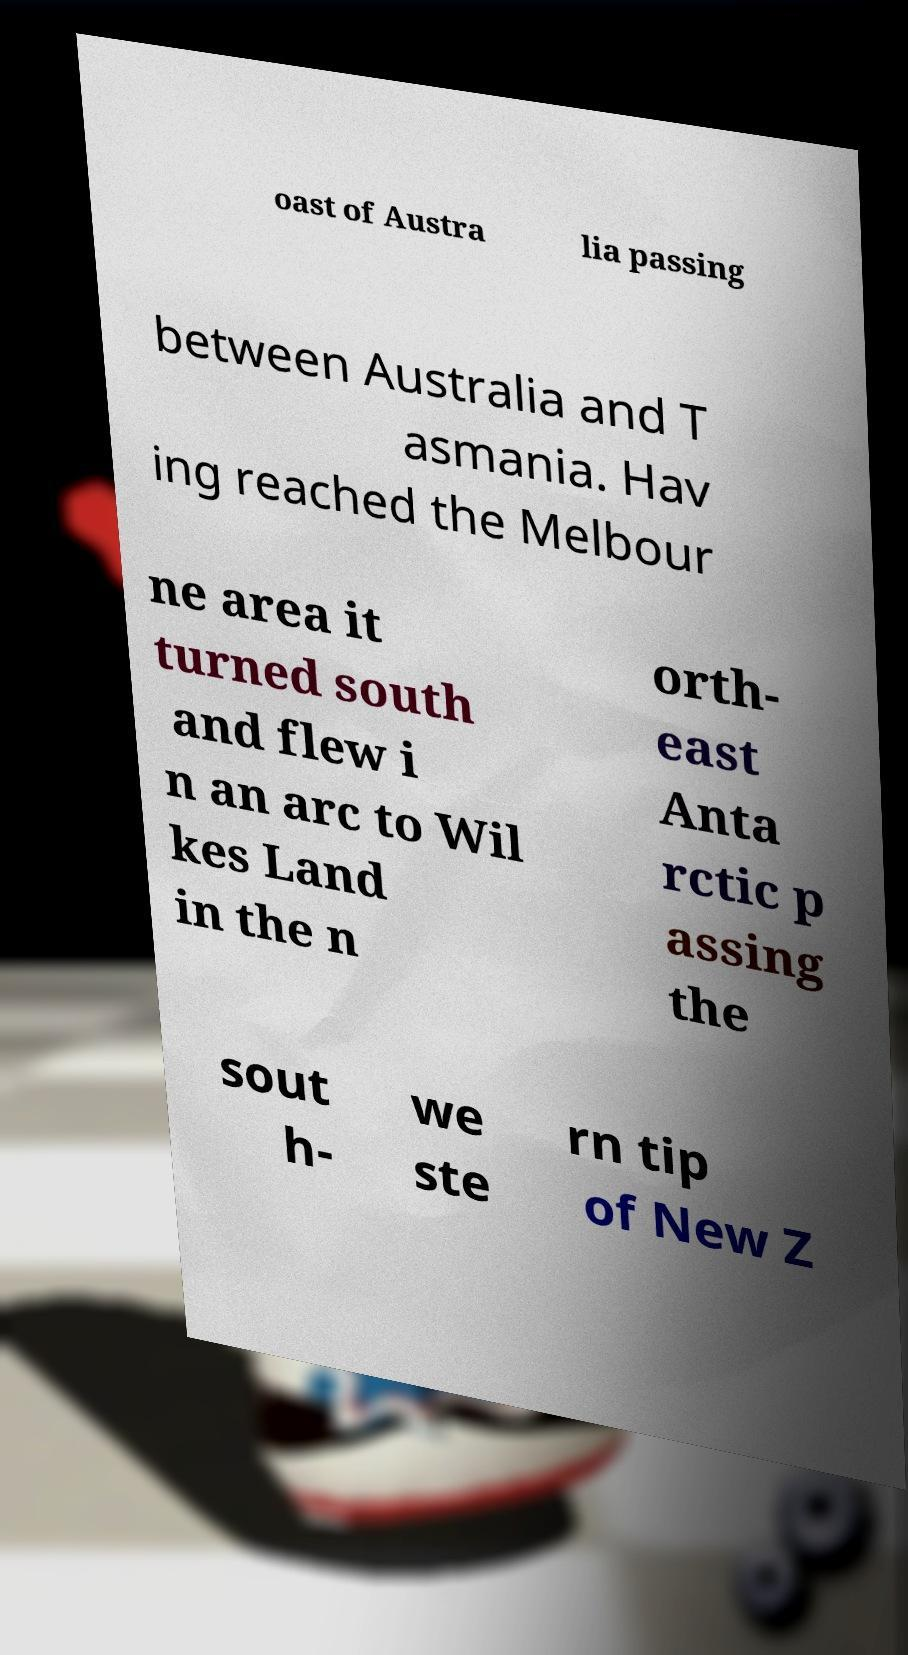Could you assist in decoding the text presented in this image and type it out clearly? oast of Austra lia passing between Australia and T asmania. Hav ing reached the Melbour ne area it turned south and flew i n an arc to Wil kes Land in the n orth- east Anta rctic p assing the sout h- we ste rn tip of New Z 